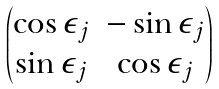<formula> <loc_0><loc_0><loc_500><loc_500>\begin{pmatrix} \cos \epsilon _ { j } & - \sin \epsilon _ { j } \\ \sin \epsilon _ { j } & \cos \epsilon _ { j } \end{pmatrix}</formula> 